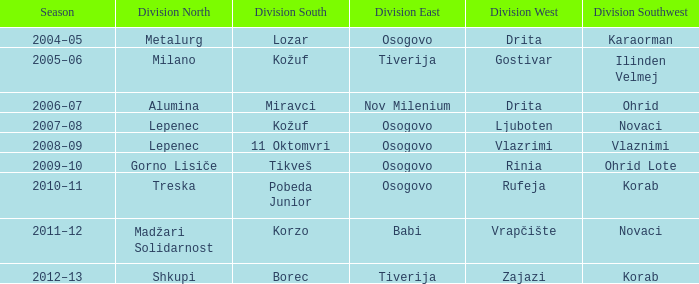Who claimed the title in division southwest when madžari solidarnost succeeded in division north? Novaci. 